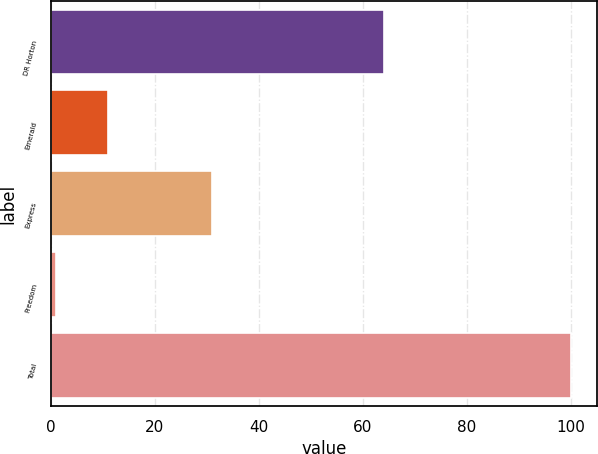Convert chart. <chart><loc_0><loc_0><loc_500><loc_500><bar_chart><fcel>DR Horton<fcel>Emerald<fcel>Express<fcel>Freedom<fcel>Total<nl><fcel>64<fcel>10.9<fcel>31<fcel>1<fcel>100<nl></chart> 